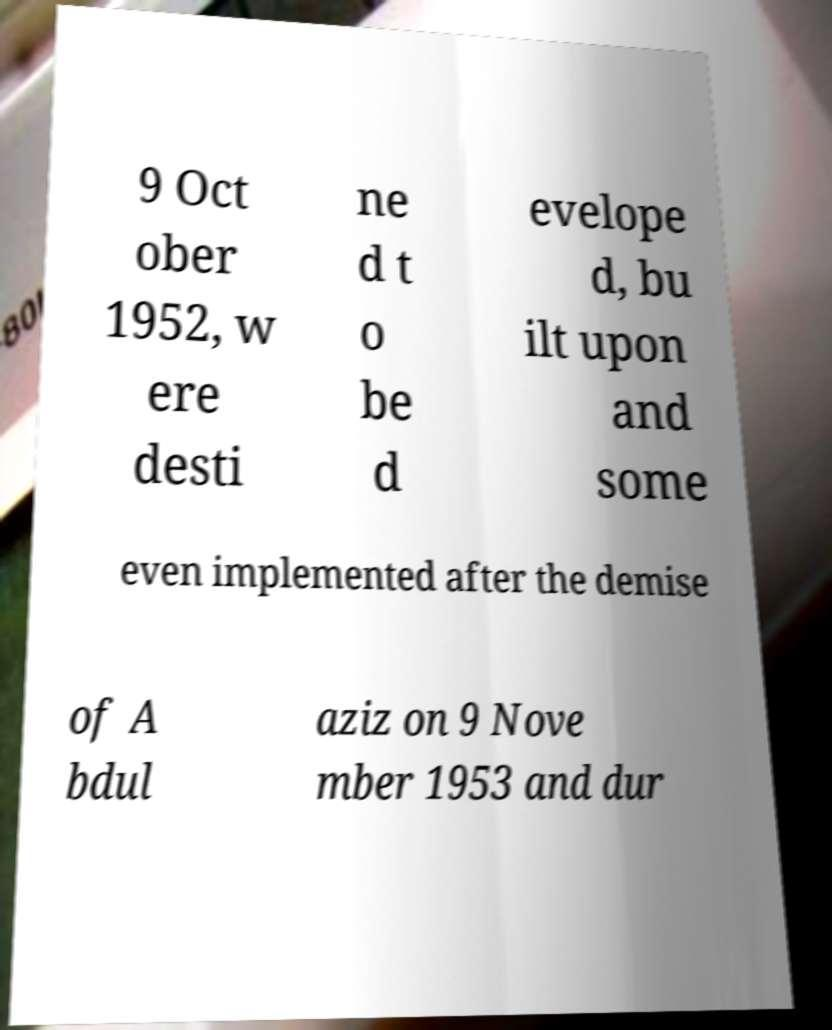Please read and relay the text visible in this image. What does it say? 9 Oct ober 1952, w ere desti ne d t o be d evelope d, bu ilt upon and some even implemented after the demise of A bdul aziz on 9 Nove mber 1953 and dur 